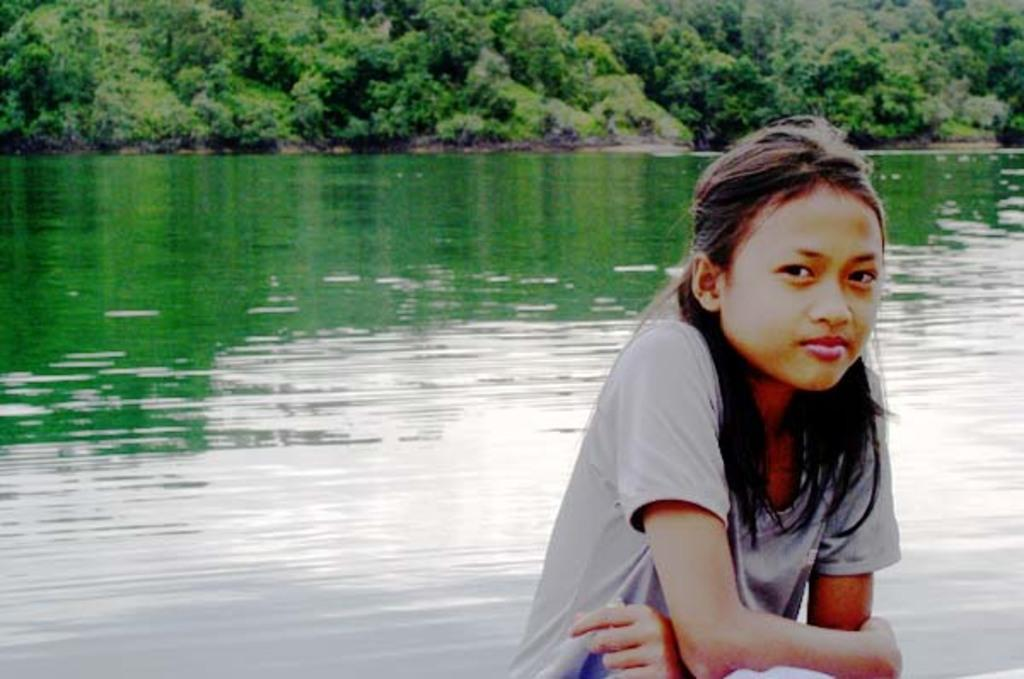Who or what is present in the image? There is a person in the image. What is the primary element visible in the image? There is water visible in the image. What type of vegetation can be seen in the image? There are green trees in the image. How many frames are present in the image? There are no frames visible in the image; it is a single photograph or scene. 